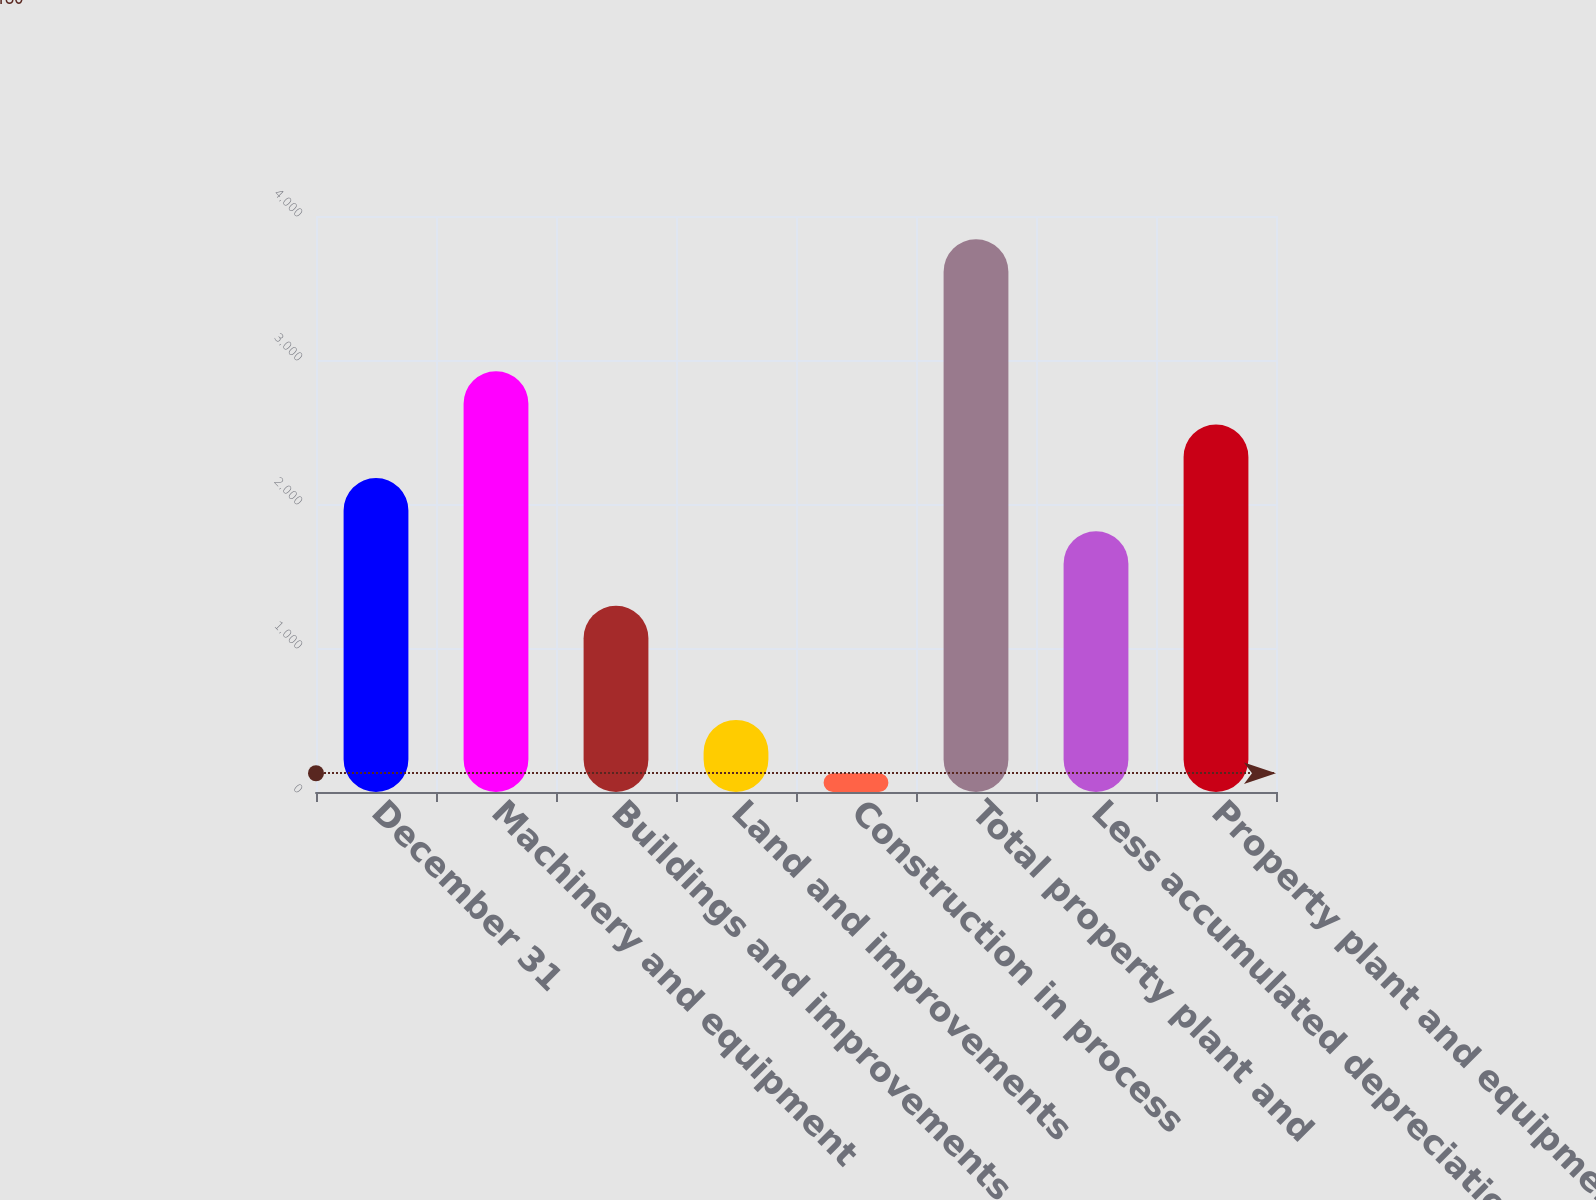Convert chart to OTSL. <chart><loc_0><loc_0><loc_500><loc_500><bar_chart><fcel>December 31<fcel>Machinery and equipment<fcel>Buildings and improvements<fcel>Land and improvements<fcel>Construction in process<fcel>Total property plant and<fcel>Less accumulated depreciation<fcel>Property plant and equipment<nl><fcel>2180.8<fcel>2922.4<fcel>1293<fcel>500.8<fcel>130<fcel>3838<fcel>1810<fcel>2551.6<nl></chart> 